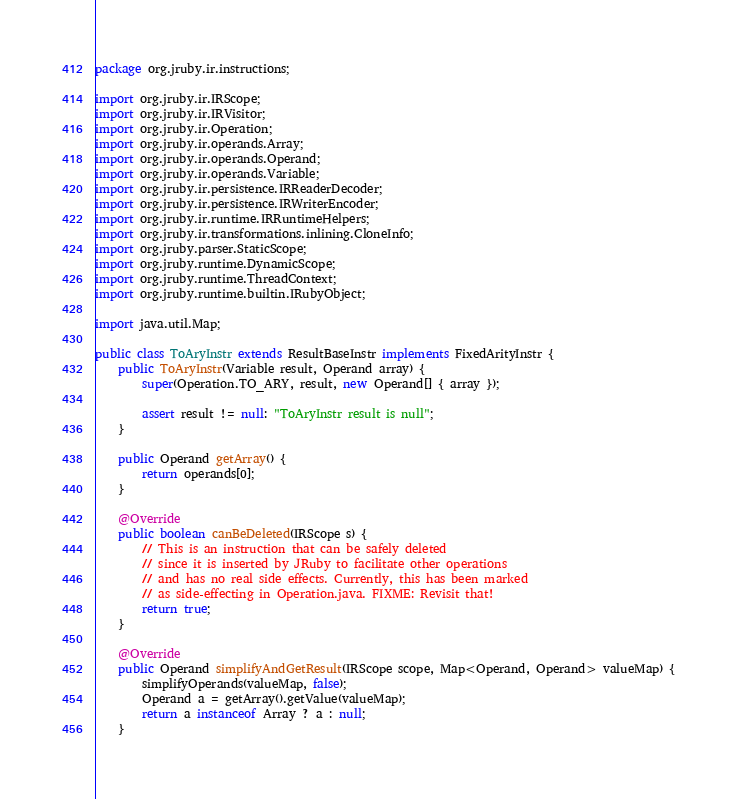Convert code to text. <code><loc_0><loc_0><loc_500><loc_500><_Java_>package org.jruby.ir.instructions;

import org.jruby.ir.IRScope;
import org.jruby.ir.IRVisitor;
import org.jruby.ir.Operation;
import org.jruby.ir.operands.Array;
import org.jruby.ir.operands.Operand;
import org.jruby.ir.operands.Variable;
import org.jruby.ir.persistence.IRReaderDecoder;
import org.jruby.ir.persistence.IRWriterEncoder;
import org.jruby.ir.runtime.IRRuntimeHelpers;
import org.jruby.ir.transformations.inlining.CloneInfo;
import org.jruby.parser.StaticScope;
import org.jruby.runtime.DynamicScope;
import org.jruby.runtime.ThreadContext;
import org.jruby.runtime.builtin.IRubyObject;

import java.util.Map;

public class ToAryInstr extends ResultBaseInstr implements FixedArityInstr {
    public ToAryInstr(Variable result, Operand array) {
        super(Operation.TO_ARY, result, new Operand[] { array });

        assert result != null: "ToAryInstr result is null";
    }

    public Operand getArray() {
        return operands[0];
    }

    @Override
    public boolean canBeDeleted(IRScope s) {
        // This is an instruction that can be safely deleted
        // since it is inserted by JRuby to facilitate other operations
        // and has no real side effects. Currently, this has been marked
        // as side-effecting in Operation.java. FIXME: Revisit that!
        return true;
    }

    @Override
    public Operand simplifyAndGetResult(IRScope scope, Map<Operand, Operand> valueMap) {
        simplifyOperands(valueMap, false);
        Operand a = getArray().getValue(valueMap);
        return a instanceof Array ? a : null;
    }
</code> 